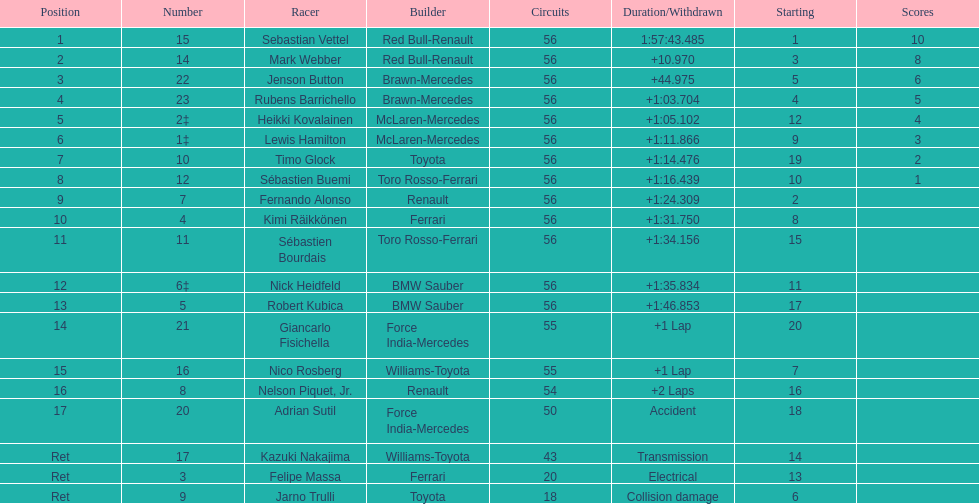What was jenson button's time? +44.975. 